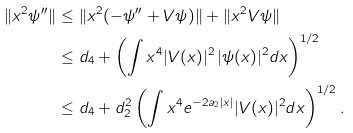Convert formula to latex. <formula><loc_0><loc_0><loc_500><loc_500>\| x ^ { 2 } \psi ^ { \prime \prime } \| & \leq \| x ^ { 2 } ( - \psi ^ { \prime \prime } + V \psi ) \| + \| x ^ { 2 } V \psi \| \\ & \leq d _ { 4 } + \left ( \int x ^ { 4 } | V ( x ) | ^ { 2 } \, | \psi ( x ) | ^ { 2 } d x \right ) ^ { 1 / 2 } \\ & \leq d _ { 4 } + d _ { 2 } ^ { 2 } \left ( \int x ^ { 4 } e ^ { - 2 a _ { 2 } | x | } | V ( x ) | ^ { 2 } d x \right ) ^ { 1 / 2 } .</formula> 